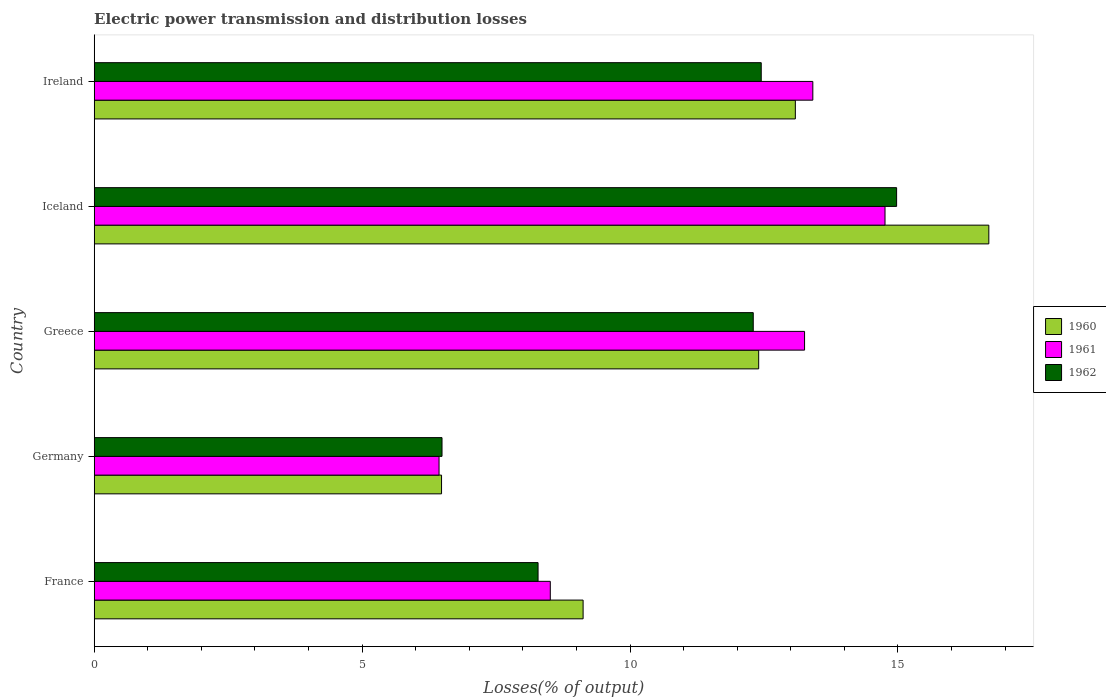How many groups of bars are there?
Provide a succinct answer. 5. Are the number of bars per tick equal to the number of legend labels?
Offer a terse response. Yes. Are the number of bars on each tick of the Y-axis equal?
Keep it short and to the point. Yes. How many bars are there on the 2nd tick from the top?
Ensure brevity in your answer.  3. In how many cases, is the number of bars for a given country not equal to the number of legend labels?
Offer a very short reply. 0. What is the electric power transmission and distribution losses in 1961 in Germany?
Make the answer very short. 6.44. Across all countries, what is the maximum electric power transmission and distribution losses in 1962?
Your answer should be very brief. 14.98. Across all countries, what is the minimum electric power transmission and distribution losses in 1962?
Offer a terse response. 6.49. In which country was the electric power transmission and distribution losses in 1960 maximum?
Give a very brief answer. Iceland. In which country was the electric power transmission and distribution losses in 1960 minimum?
Provide a short and direct response. Germany. What is the total electric power transmission and distribution losses in 1962 in the graph?
Make the answer very short. 54.5. What is the difference between the electric power transmission and distribution losses in 1960 in France and that in Iceland?
Your answer should be compact. -7.57. What is the difference between the electric power transmission and distribution losses in 1960 in Germany and the electric power transmission and distribution losses in 1962 in France?
Your answer should be compact. -1.8. What is the average electric power transmission and distribution losses in 1962 per country?
Ensure brevity in your answer.  10.9. What is the difference between the electric power transmission and distribution losses in 1961 and electric power transmission and distribution losses in 1962 in Iceland?
Your answer should be very brief. -0.22. What is the ratio of the electric power transmission and distribution losses in 1962 in France to that in Ireland?
Ensure brevity in your answer.  0.67. Is the difference between the electric power transmission and distribution losses in 1961 in Germany and Greece greater than the difference between the electric power transmission and distribution losses in 1962 in Germany and Greece?
Provide a short and direct response. No. What is the difference between the highest and the second highest electric power transmission and distribution losses in 1961?
Keep it short and to the point. 1.35. What is the difference between the highest and the lowest electric power transmission and distribution losses in 1962?
Ensure brevity in your answer.  8.48. What does the 3rd bar from the top in France represents?
Give a very brief answer. 1960. What does the 2nd bar from the bottom in France represents?
Make the answer very short. 1961. Is it the case that in every country, the sum of the electric power transmission and distribution losses in 1961 and electric power transmission and distribution losses in 1960 is greater than the electric power transmission and distribution losses in 1962?
Provide a short and direct response. Yes. Are all the bars in the graph horizontal?
Your answer should be very brief. Yes. How many countries are there in the graph?
Make the answer very short. 5. Does the graph contain any zero values?
Your answer should be very brief. No. How many legend labels are there?
Keep it short and to the point. 3. How are the legend labels stacked?
Offer a terse response. Vertical. What is the title of the graph?
Your answer should be very brief. Electric power transmission and distribution losses. Does "1984" appear as one of the legend labels in the graph?
Offer a very short reply. No. What is the label or title of the X-axis?
Provide a succinct answer. Losses(% of output). What is the label or title of the Y-axis?
Provide a short and direct response. Country. What is the Losses(% of output) in 1960 in France?
Provide a succinct answer. 9.12. What is the Losses(% of output) of 1961 in France?
Keep it short and to the point. 8.51. What is the Losses(% of output) of 1962 in France?
Provide a short and direct response. 8.28. What is the Losses(% of output) in 1960 in Germany?
Ensure brevity in your answer.  6.48. What is the Losses(% of output) in 1961 in Germany?
Ensure brevity in your answer.  6.44. What is the Losses(% of output) in 1962 in Germany?
Provide a succinct answer. 6.49. What is the Losses(% of output) of 1960 in Greece?
Make the answer very short. 12.4. What is the Losses(% of output) of 1961 in Greece?
Make the answer very short. 13.26. What is the Losses(% of output) in 1962 in Greece?
Provide a succinct answer. 12.3. What is the Losses(% of output) of 1960 in Iceland?
Keep it short and to the point. 16.7. What is the Losses(% of output) of 1961 in Iceland?
Your response must be concise. 14.76. What is the Losses(% of output) in 1962 in Iceland?
Your answer should be very brief. 14.98. What is the Losses(% of output) in 1960 in Ireland?
Provide a short and direct response. 13.09. What is the Losses(% of output) of 1961 in Ireland?
Your answer should be compact. 13.41. What is the Losses(% of output) of 1962 in Ireland?
Ensure brevity in your answer.  12.45. Across all countries, what is the maximum Losses(% of output) in 1960?
Ensure brevity in your answer.  16.7. Across all countries, what is the maximum Losses(% of output) of 1961?
Your answer should be very brief. 14.76. Across all countries, what is the maximum Losses(% of output) in 1962?
Offer a very short reply. 14.98. Across all countries, what is the minimum Losses(% of output) in 1960?
Provide a short and direct response. 6.48. Across all countries, what is the minimum Losses(% of output) of 1961?
Ensure brevity in your answer.  6.44. Across all countries, what is the minimum Losses(% of output) in 1962?
Provide a short and direct response. 6.49. What is the total Losses(% of output) in 1960 in the graph?
Your answer should be compact. 57.79. What is the total Losses(% of output) in 1961 in the graph?
Provide a short and direct response. 56.38. What is the total Losses(% of output) of 1962 in the graph?
Ensure brevity in your answer.  54.5. What is the difference between the Losses(% of output) of 1960 in France and that in Germany?
Make the answer very short. 2.64. What is the difference between the Losses(% of output) of 1961 in France and that in Germany?
Your answer should be very brief. 2.08. What is the difference between the Losses(% of output) in 1962 in France and that in Germany?
Make the answer very short. 1.79. What is the difference between the Losses(% of output) of 1960 in France and that in Greece?
Provide a succinct answer. -3.28. What is the difference between the Losses(% of output) of 1961 in France and that in Greece?
Keep it short and to the point. -4.75. What is the difference between the Losses(% of output) of 1962 in France and that in Greece?
Offer a very short reply. -4.02. What is the difference between the Losses(% of output) in 1960 in France and that in Iceland?
Ensure brevity in your answer.  -7.57. What is the difference between the Losses(% of output) in 1961 in France and that in Iceland?
Offer a very short reply. -6.25. What is the difference between the Losses(% of output) in 1962 in France and that in Iceland?
Your response must be concise. -6.69. What is the difference between the Losses(% of output) in 1960 in France and that in Ireland?
Offer a terse response. -3.96. What is the difference between the Losses(% of output) of 1961 in France and that in Ireland?
Offer a very short reply. -4.9. What is the difference between the Losses(% of output) of 1962 in France and that in Ireland?
Offer a very short reply. -4.17. What is the difference between the Losses(% of output) in 1960 in Germany and that in Greece?
Your answer should be very brief. -5.92. What is the difference between the Losses(% of output) of 1961 in Germany and that in Greece?
Ensure brevity in your answer.  -6.82. What is the difference between the Losses(% of output) in 1962 in Germany and that in Greece?
Make the answer very short. -5.81. What is the difference between the Losses(% of output) in 1960 in Germany and that in Iceland?
Ensure brevity in your answer.  -10.21. What is the difference between the Losses(% of output) of 1961 in Germany and that in Iceland?
Ensure brevity in your answer.  -8.32. What is the difference between the Losses(% of output) of 1962 in Germany and that in Iceland?
Provide a succinct answer. -8.48. What is the difference between the Losses(% of output) in 1960 in Germany and that in Ireland?
Provide a succinct answer. -6.6. What is the difference between the Losses(% of output) in 1961 in Germany and that in Ireland?
Provide a short and direct response. -6.98. What is the difference between the Losses(% of output) in 1962 in Germany and that in Ireland?
Keep it short and to the point. -5.96. What is the difference between the Losses(% of output) of 1960 in Greece and that in Iceland?
Ensure brevity in your answer.  -4.3. What is the difference between the Losses(% of output) of 1961 in Greece and that in Iceland?
Provide a succinct answer. -1.5. What is the difference between the Losses(% of output) in 1962 in Greece and that in Iceland?
Offer a very short reply. -2.68. What is the difference between the Losses(% of output) in 1960 in Greece and that in Ireland?
Your response must be concise. -0.68. What is the difference between the Losses(% of output) in 1961 in Greece and that in Ireland?
Offer a terse response. -0.15. What is the difference between the Losses(% of output) of 1962 in Greece and that in Ireland?
Make the answer very short. -0.15. What is the difference between the Losses(% of output) of 1960 in Iceland and that in Ireland?
Your answer should be very brief. 3.61. What is the difference between the Losses(% of output) of 1961 in Iceland and that in Ireland?
Keep it short and to the point. 1.35. What is the difference between the Losses(% of output) in 1962 in Iceland and that in Ireland?
Ensure brevity in your answer.  2.53. What is the difference between the Losses(% of output) of 1960 in France and the Losses(% of output) of 1961 in Germany?
Your answer should be very brief. 2.69. What is the difference between the Losses(% of output) of 1960 in France and the Losses(% of output) of 1962 in Germany?
Provide a succinct answer. 2.63. What is the difference between the Losses(% of output) of 1961 in France and the Losses(% of output) of 1962 in Germany?
Give a very brief answer. 2.02. What is the difference between the Losses(% of output) of 1960 in France and the Losses(% of output) of 1961 in Greece?
Your answer should be compact. -4.13. What is the difference between the Losses(% of output) of 1960 in France and the Losses(% of output) of 1962 in Greece?
Provide a succinct answer. -3.18. What is the difference between the Losses(% of output) of 1961 in France and the Losses(% of output) of 1962 in Greece?
Give a very brief answer. -3.79. What is the difference between the Losses(% of output) of 1960 in France and the Losses(% of output) of 1961 in Iceland?
Provide a short and direct response. -5.63. What is the difference between the Losses(% of output) of 1960 in France and the Losses(% of output) of 1962 in Iceland?
Give a very brief answer. -5.85. What is the difference between the Losses(% of output) of 1961 in France and the Losses(% of output) of 1962 in Iceland?
Keep it short and to the point. -6.46. What is the difference between the Losses(% of output) in 1960 in France and the Losses(% of output) in 1961 in Ireland?
Ensure brevity in your answer.  -4.29. What is the difference between the Losses(% of output) of 1960 in France and the Losses(% of output) of 1962 in Ireland?
Ensure brevity in your answer.  -3.32. What is the difference between the Losses(% of output) in 1961 in France and the Losses(% of output) in 1962 in Ireland?
Give a very brief answer. -3.94. What is the difference between the Losses(% of output) in 1960 in Germany and the Losses(% of output) in 1961 in Greece?
Provide a short and direct response. -6.78. What is the difference between the Losses(% of output) in 1960 in Germany and the Losses(% of output) in 1962 in Greece?
Provide a short and direct response. -5.82. What is the difference between the Losses(% of output) of 1961 in Germany and the Losses(% of output) of 1962 in Greece?
Your answer should be very brief. -5.86. What is the difference between the Losses(% of output) of 1960 in Germany and the Losses(% of output) of 1961 in Iceland?
Provide a short and direct response. -8.28. What is the difference between the Losses(% of output) in 1960 in Germany and the Losses(% of output) in 1962 in Iceland?
Offer a terse response. -8.49. What is the difference between the Losses(% of output) of 1961 in Germany and the Losses(% of output) of 1962 in Iceland?
Provide a short and direct response. -8.54. What is the difference between the Losses(% of output) of 1960 in Germany and the Losses(% of output) of 1961 in Ireland?
Your answer should be compact. -6.93. What is the difference between the Losses(% of output) in 1960 in Germany and the Losses(% of output) in 1962 in Ireland?
Ensure brevity in your answer.  -5.97. What is the difference between the Losses(% of output) in 1961 in Germany and the Losses(% of output) in 1962 in Ireland?
Provide a succinct answer. -6.01. What is the difference between the Losses(% of output) of 1960 in Greece and the Losses(% of output) of 1961 in Iceland?
Offer a terse response. -2.36. What is the difference between the Losses(% of output) of 1960 in Greece and the Losses(% of output) of 1962 in Iceland?
Your answer should be very brief. -2.57. What is the difference between the Losses(% of output) in 1961 in Greece and the Losses(% of output) in 1962 in Iceland?
Ensure brevity in your answer.  -1.72. What is the difference between the Losses(% of output) in 1960 in Greece and the Losses(% of output) in 1961 in Ireland?
Your answer should be compact. -1.01. What is the difference between the Losses(% of output) in 1960 in Greece and the Losses(% of output) in 1962 in Ireland?
Ensure brevity in your answer.  -0.05. What is the difference between the Losses(% of output) of 1961 in Greece and the Losses(% of output) of 1962 in Ireland?
Offer a very short reply. 0.81. What is the difference between the Losses(% of output) in 1960 in Iceland and the Losses(% of output) in 1961 in Ireland?
Your answer should be compact. 3.28. What is the difference between the Losses(% of output) in 1960 in Iceland and the Losses(% of output) in 1962 in Ireland?
Your response must be concise. 4.25. What is the difference between the Losses(% of output) in 1961 in Iceland and the Losses(% of output) in 1962 in Ireland?
Your answer should be compact. 2.31. What is the average Losses(% of output) of 1960 per country?
Your answer should be compact. 11.56. What is the average Losses(% of output) of 1961 per country?
Offer a very short reply. 11.28. What is the average Losses(% of output) in 1962 per country?
Give a very brief answer. 10.9. What is the difference between the Losses(% of output) of 1960 and Losses(% of output) of 1961 in France?
Your response must be concise. 0.61. What is the difference between the Losses(% of output) of 1960 and Losses(% of output) of 1962 in France?
Make the answer very short. 0.84. What is the difference between the Losses(% of output) of 1961 and Losses(% of output) of 1962 in France?
Your response must be concise. 0.23. What is the difference between the Losses(% of output) in 1960 and Losses(% of output) in 1961 in Germany?
Your answer should be compact. 0.05. What is the difference between the Losses(% of output) in 1960 and Losses(% of output) in 1962 in Germany?
Give a very brief answer. -0.01. What is the difference between the Losses(% of output) in 1961 and Losses(% of output) in 1962 in Germany?
Offer a very short reply. -0.06. What is the difference between the Losses(% of output) of 1960 and Losses(% of output) of 1961 in Greece?
Ensure brevity in your answer.  -0.86. What is the difference between the Losses(% of output) of 1960 and Losses(% of output) of 1962 in Greece?
Ensure brevity in your answer.  0.1. What is the difference between the Losses(% of output) in 1961 and Losses(% of output) in 1962 in Greece?
Your answer should be compact. 0.96. What is the difference between the Losses(% of output) in 1960 and Losses(% of output) in 1961 in Iceland?
Offer a very short reply. 1.94. What is the difference between the Losses(% of output) of 1960 and Losses(% of output) of 1962 in Iceland?
Provide a succinct answer. 1.72. What is the difference between the Losses(% of output) of 1961 and Losses(% of output) of 1962 in Iceland?
Your answer should be very brief. -0.22. What is the difference between the Losses(% of output) in 1960 and Losses(% of output) in 1961 in Ireland?
Give a very brief answer. -0.33. What is the difference between the Losses(% of output) in 1960 and Losses(% of output) in 1962 in Ireland?
Offer a very short reply. 0.64. What is the difference between the Losses(% of output) in 1961 and Losses(% of output) in 1962 in Ireland?
Give a very brief answer. 0.96. What is the ratio of the Losses(% of output) of 1960 in France to that in Germany?
Provide a short and direct response. 1.41. What is the ratio of the Losses(% of output) in 1961 in France to that in Germany?
Offer a terse response. 1.32. What is the ratio of the Losses(% of output) of 1962 in France to that in Germany?
Ensure brevity in your answer.  1.28. What is the ratio of the Losses(% of output) of 1960 in France to that in Greece?
Offer a terse response. 0.74. What is the ratio of the Losses(% of output) of 1961 in France to that in Greece?
Provide a short and direct response. 0.64. What is the ratio of the Losses(% of output) in 1962 in France to that in Greece?
Your answer should be compact. 0.67. What is the ratio of the Losses(% of output) of 1960 in France to that in Iceland?
Keep it short and to the point. 0.55. What is the ratio of the Losses(% of output) in 1961 in France to that in Iceland?
Your response must be concise. 0.58. What is the ratio of the Losses(% of output) in 1962 in France to that in Iceland?
Ensure brevity in your answer.  0.55. What is the ratio of the Losses(% of output) of 1960 in France to that in Ireland?
Give a very brief answer. 0.7. What is the ratio of the Losses(% of output) of 1961 in France to that in Ireland?
Make the answer very short. 0.63. What is the ratio of the Losses(% of output) of 1962 in France to that in Ireland?
Keep it short and to the point. 0.67. What is the ratio of the Losses(% of output) in 1960 in Germany to that in Greece?
Offer a very short reply. 0.52. What is the ratio of the Losses(% of output) of 1961 in Germany to that in Greece?
Your answer should be very brief. 0.49. What is the ratio of the Losses(% of output) of 1962 in Germany to that in Greece?
Your response must be concise. 0.53. What is the ratio of the Losses(% of output) in 1960 in Germany to that in Iceland?
Your answer should be compact. 0.39. What is the ratio of the Losses(% of output) in 1961 in Germany to that in Iceland?
Give a very brief answer. 0.44. What is the ratio of the Losses(% of output) in 1962 in Germany to that in Iceland?
Your answer should be very brief. 0.43. What is the ratio of the Losses(% of output) of 1960 in Germany to that in Ireland?
Offer a very short reply. 0.5. What is the ratio of the Losses(% of output) of 1961 in Germany to that in Ireland?
Your response must be concise. 0.48. What is the ratio of the Losses(% of output) of 1962 in Germany to that in Ireland?
Your answer should be very brief. 0.52. What is the ratio of the Losses(% of output) in 1960 in Greece to that in Iceland?
Provide a short and direct response. 0.74. What is the ratio of the Losses(% of output) of 1961 in Greece to that in Iceland?
Offer a very short reply. 0.9. What is the ratio of the Losses(% of output) of 1962 in Greece to that in Iceland?
Ensure brevity in your answer.  0.82. What is the ratio of the Losses(% of output) in 1960 in Greece to that in Ireland?
Offer a terse response. 0.95. What is the ratio of the Losses(% of output) of 1961 in Greece to that in Ireland?
Ensure brevity in your answer.  0.99. What is the ratio of the Losses(% of output) in 1960 in Iceland to that in Ireland?
Provide a succinct answer. 1.28. What is the ratio of the Losses(% of output) in 1961 in Iceland to that in Ireland?
Keep it short and to the point. 1.1. What is the ratio of the Losses(% of output) of 1962 in Iceland to that in Ireland?
Offer a terse response. 1.2. What is the difference between the highest and the second highest Losses(% of output) of 1960?
Give a very brief answer. 3.61. What is the difference between the highest and the second highest Losses(% of output) of 1961?
Your answer should be compact. 1.35. What is the difference between the highest and the second highest Losses(% of output) of 1962?
Your answer should be very brief. 2.53. What is the difference between the highest and the lowest Losses(% of output) in 1960?
Offer a terse response. 10.21. What is the difference between the highest and the lowest Losses(% of output) of 1961?
Keep it short and to the point. 8.32. What is the difference between the highest and the lowest Losses(% of output) in 1962?
Make the answer very short. 8.48. 